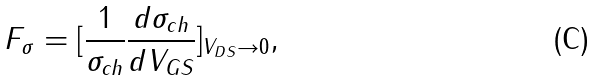<formula> <loc_0><loc_0><loc_500><loc_500>F _ { \sigma } = [ \frac { 1 } { \sigma _ { c h } } \frac { d \sigma _ { c h } } { d V _ { G S } } ] _ { V _ { D S } \rightarrow 0 } ,</formula> 